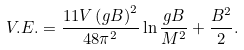<formula> <loc_0><loc_0><loc_500><loc_500>V . E . = \frac { 1 1 V \left ( g B \right ) ^ { 2 } } { 4 8 \pi ^ { 2 } } \ln \frac { g B } { M ^ { 2 } } + \frac { B ^ { 2 } } { 2 } .</formula> 